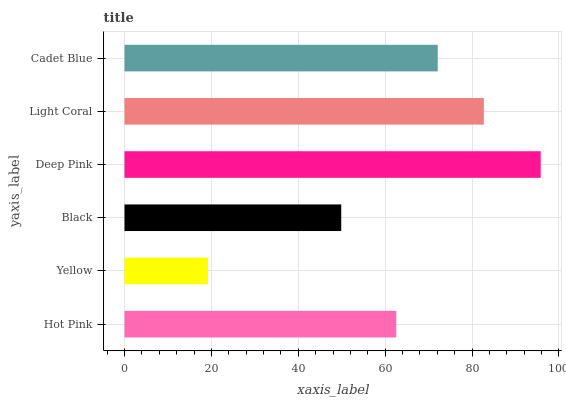Is Yellow the minimum?
Answer yes or no. Yes. Is Deep Pink the maximum?
Answer yes or no. Yes. Is Black the minimum?
Answer yes or no. No. Is Black the maximum?
Answer yes or no. No. Is Black greater than Yellow?
Answer yes or no. Yes. Is Yellow less than Black?
Answer yes or no. Yes. Is Yellow greater than Black?
Answer yes or no. No. Is Black less than Yellow?
Answer yes or no. No. Is Cadet Blue the high median?
Answer yes or no. Yes. Is Hot Pink the low median?
Answer yes or no. Yes. Is Yellow the high median?
Answer yes or no. No. Is Black the low median?
Answer yes or no. No. 